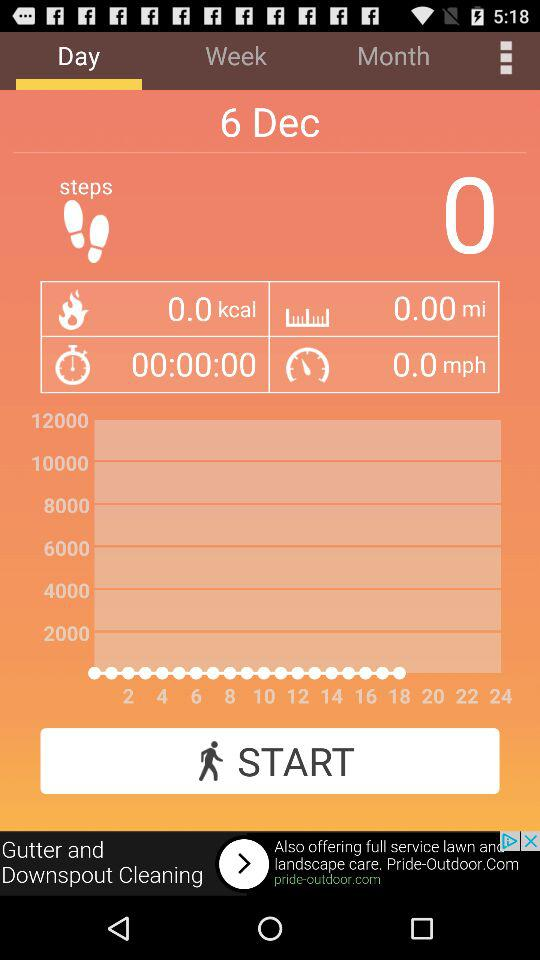What is the total number of calories burned? The total number of calories burned is 0.0 kcal. 